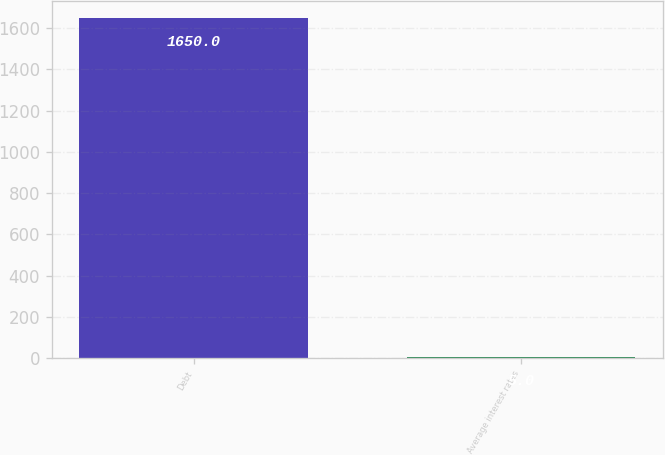Convert chart. <chart><loc_0><loc_0><loc_500><loc_500><bar_chart><fcel>Debt<fcel>Average interest rates<nl><fcel>1650<fcel>5<nl></chart> 